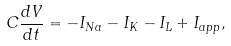<formula> <loc_0><loc_0><loc_500><loc_500>C \frac { d V } { d t } = - I _ { N a } - I _ { K } - I _ { L } + I _ { a p p } ,</formula> 